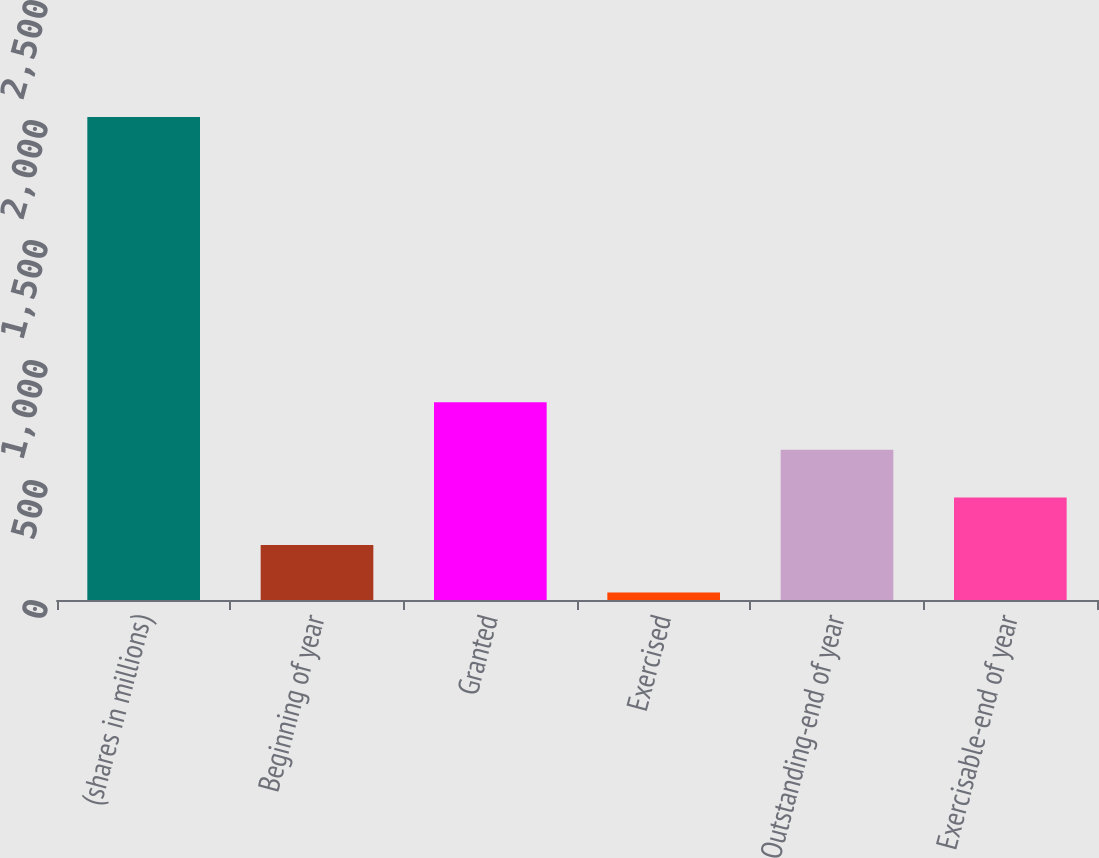Convert chart to OTSL. <chart><loc_0><loc_0><loc_500><loc_500><bar_chart><fcel>(shares in millions)<fcel>Beginning of year<fcel>Granted<fcel>Exercised<fcel>Outstanding-end of year<fcel>Exercisable-end of year<nl><fcel>2012<fcel>229.49<fcel>823.67<fcel>31.43<fcel>625.61<fcel>427.55<nl></chart> 